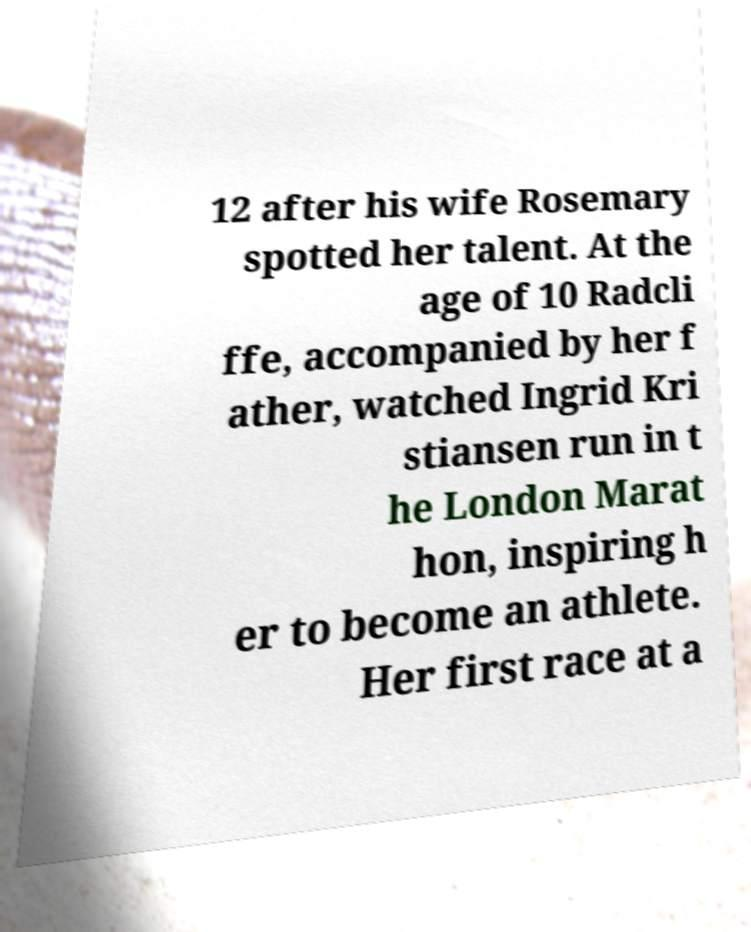I need the written content from this picture converted into text. Can you do that? 12 after his wife Rosemary spotted her talent. At the age of 10 Radcli ffe, accompanied by her f ather, watched Ingrid Kri stiansen run in t he London Marat hon, inspiring h er to become an athlete. Her first race at a 